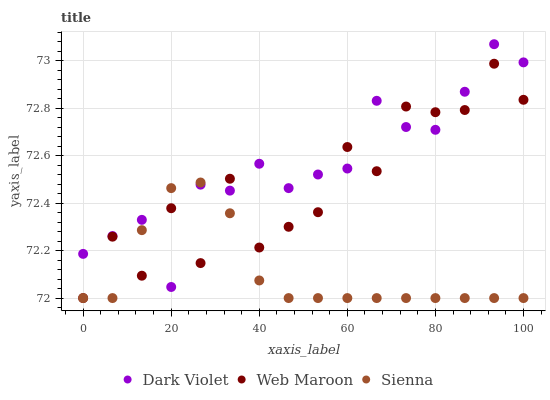Does Sienna have the minimum area under the curve?
Answer yes or no. Yes. Does Dark Violet have the maximum area under the curve?
Answer yes or no. Yes. Does Web Maroon have the minimum area under the curve?
Answer yes or no. No. Does Web Maroon have the maximum area under the curve?
Answer yes or no. No. Is Sienna the smoothest?
Answer yes or no. Yes. Is Web Maroon the roughest?
Answer yes or no. Yes. Is Dark Violet the smoothest?
Answer yes or no. No. Is Dark Violet the roughest?
Answer yes or no. No. Does Sienna have the lowest value?
Answer yes or no. Yes. Does Dark Violet have the lowest value?
Answer yes or no. No. Does Dark Violet have the highest value?
Answer yes or no. Yes. Does Web Maroon have the highest value?
Answer yes or no. No. Does Dark Violet intersect Web Maroon?
Answer yes or no. Yes. Is Dark Violet less than Web Maroon?
Answer yes or no. No. Is Dark Violet greater than Web Maroon?
Answer yes or no. No. 